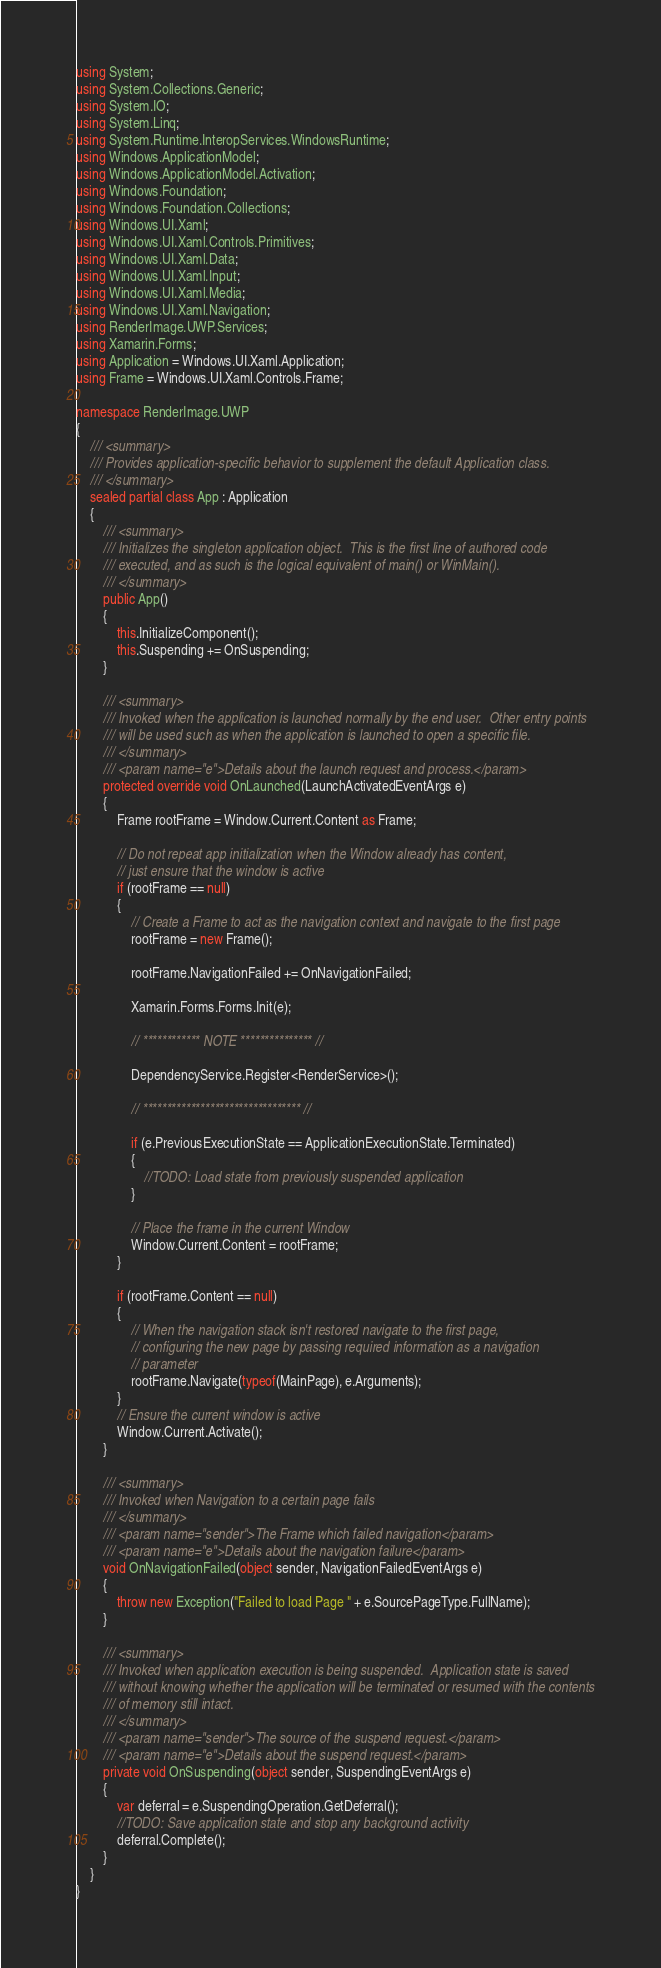<code> <loc_0><loc_0><loc_500><loc_500><_C#_>using System;
using System.Collections.Generic;
using System.IO;
using System.Linq;
using System.Runtime.InteropServices.WindowsRuntime;
using Windows.ApplicationModel;
using Windows.ApplicationModel.Activation;
using Windows.Foundation;
using Windows.Foundation.Collections;
using Windows.UI.Xaml;
using Windows.UI.Xaml.Controls.Primitives;
using Windows.UI.Xaml.Data;
using Windows.UI.Xaml.Input;
using Windows.UI.Xaml.Media;
using Windows.UI.Xaml.Navigation;
using RenderImage.UWP.Services;
using Xamarin.Forms;
using Application = Windows.UI.Xaml.Application;
using Frame = Windows.UI.Xaml.Controls.Frame;

namespace RenderImage.UWP
{
    /// <summary>
    /// Provides application-specific behavior to supplement the default Application class.
    /// </summary>
    sealed partial class App : Application
    {
        /// <summary>
        /// Initializes the singleton application object.  This is the first line of authored code
        /// executed, and as such is the logical equivalent of main() or WinMain().
        /// </summary>
        public App()
        {
            this.InitializeComponent();
            this.Suspending += OnSuspending;
        }

        /// <summary>
        /// Invoked when the application is launched normally by the end user.  Other entry points
        /// will be used such as when the application is launched to open a specific file.
        /// </summary>
        /// <param name="e">Details about the launch request and process.</param>
        protected override void OnLaunched(LaunchActivatedEventArgs e)
        {
            Frame rootFrame = Window.Current.Content as Frame;

            // Do not repeat app initialization when the Window already has content,
            // just ensure that the window is active
            if (rootFrame == null)
            {
                // Create a Frame to act as the navigation context and navigate to the first page
                rootFrame = new Frame();

                rootFrame.NavigationFailed += OnNavigationFailed;

                Xamarin.Forms.Forms.Init(e);

                // ************ NOTE *************** //

                DependencyService.Register<RenderService>();

                // ********************************* //

                if (e.PreviousExecutionState == ApplicationExecutionState.Terminated)
                {
                    //TODO: Load state from previously suspended application
                }
                
                // Place the frame in the current Window
                Window.Current.Content = rootFrame;
            }

            if (rootFrame.Content == null)
            {
                // When the navigation stack isn't restored navigate to the first page,
                // configuring the new page by passing required information as a navigation
                // parameter
                rootFrame.Navigate(typeof(MainPage), e.Arguments);
            }
            // Ensure the current window is active
            Window.Current.Activate();
        }

        /// <summary>
        /// Invoked when Navigation to a certain page fails
        /// </summary>
        /// <param name="sender">The Frame which failed navigation</param>
        /// <param name="e">Details about the navigation failure</param>
        void OnNavigationFailed(object sender, NavigationFailedEventArgs e)
        {
            throw new Exception("Failed to load Page " + e.SourcePageType.FullName);
        }

        /// <summary>
        /// Invoked when application execution is being suspended.  Application state is saved
        /// without knowing whether the application will be terminated or resumed with the contents
        /// of memory still intact.
        /// </summary>
        /// <param name="sender">The source of the suspend request.</param>
        /// <param name="e">Details about the suspend request.</param>
        private void OnSuspending(object sender, SuspendingEventArgs e)
        {
            var deferral = e.SuspendingOperation.GetDeferral();
            //TODO: Save application state and stop any background activity
            deferral.Complete();
        }
    }
}
</code> 